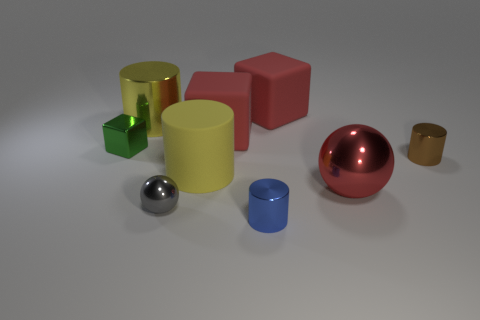Is the size of the blue metallic thing the same as the gray object that is on the right side of the green metallic thing?
Offer a very short reply. Yes. There is a cylinder that is on the left side of the tiny blue metal thing and in front of the small green metallic thing; how big is it?
Keep it short and to the point. Large. Are there any big blocks that have the same color as the big sphere?
Offer a very short reply. Yes. The metal cylinder in front of the cylinder on the right side of the blue object is what color?
Keep it short and to the point. Blue. Is the number of green metal cubes in front of the blue metal object less than the number of large red metal balls left of the small gray thing?
Provide a short and direct response. No. Do the green block and the brown shiny thing have the same size?
Give a very brief answer. Yes. There is a large thing that is in front of the metal block and left of the red metallic sphere; what shape is it?
Provide a short and direct response. Cylinder. What number of blue objects are made of the same material as the small green block?
Ensure brevity in your answer.  1. What number of matte blocks are to the left of the big yellow object left of the small gray metal ball?
Offer a terse response. 0. There is a tiny green thing that is behind the sphere that is to the right of the small metallic cylinder that is left of the red sphere; what shape is it?
Your answer should be very brief. Cube. 